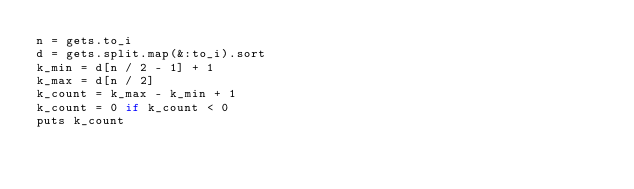Convert code to text. <code><loc_0><loc_0><loc_500><loc_500><_Ruby_>n = gets.to_i
d = gets.split.map(&:to_i).sort
k_min = d[n / 2 - 1] + 1
k_max = d[n / 2]
k_count = k_max - k_min + 1
k_count = 0 if k_count < 0
puts k_count
</code> 